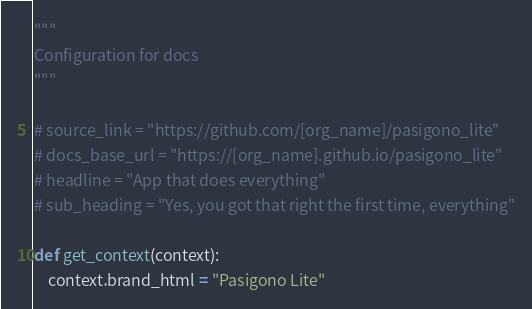Convert code to text. <code><loc_0><loc_0><loc_500><loc_500><_Python_>"""
Configuration for docs
"""

# source_link = "https://github.com/[org_name]/pasigono_lite"
# docs_base_url = "https://[org_name].github.io/pasigono_lite"
# headline = "App that does everything"
# sub_heading = "Yes, you got that right the first time, everything"

def get_context(context):
	context.brand_html = "Pasigono Lite"
</code> 